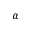<formula> <loc_0><loc_0><loc_500><loc_500>\alpha</formula> 